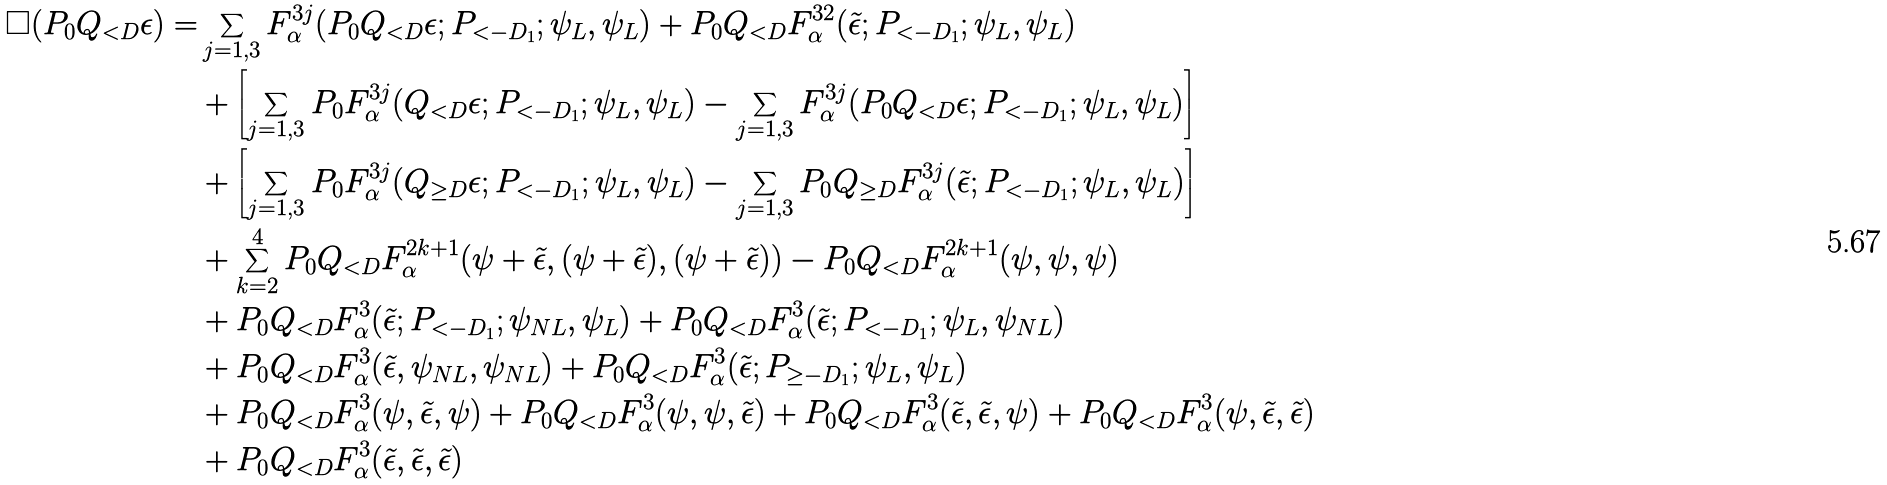<formula> <loc_0><loc_0><loc_500><loc_500>\Box ( P _ { 0 } Q _ { < D } \epsilon ) = & \sum _ { j = 1 , 3 } F _ { \alpha } ^ { 3 j } ( P _ { 0 } Q _ { < D } \epsilon ; P _ { < - D _ { 1 } } ; \psi _ { L } , \psi _ { L } ) + P _ { 0 } Q _ { < D } F _ { \alpha } ^ { 3 2 } ( \tilde { \epsilon } ; P _ { < - D _ { 1 } } ; \psi _ { L } , \psi _ { L } ) \\ & + \left [ \sum _ { j = 1 , 3 } P _ { 0 } F _ { \alpha } ^ { 3 j } ( Q _ { < D } \epsilon ; P _ { < - D _ { 1 } } ; \psi _ { L } , \psi _ { L } ) - \sum _ { j = 1 , 3 } F _ { \alpha } ^ { 3 j } ( P _ { 0 } Q _ { < D } \epsilon ; P _ { < - D _ { 1 } } ; \psi _ { L } , \psi _ { L } ) \right ] \\ & + \left [ \sum _ { j = 1 , 3 } P _ { 0 } F _ { \alpha } ^ { 3 j } ( Q _ { \geq D } \epsilon ; P _ { < - D _ { 1 } } ; \psi _ { L } , \psi _ { L } ) - \sum _ { j = 1 , 3 } P _ { 0 } Q _ { \geq D } F _ { \alpha } ^ { 3 j } ( \tilde { \epsilon } ; P _ { < - D _ { 1 } } ; \psi _ { L } , \psi _ { L } ) \right ] \\ & + \sum _ { k = 2 } ^ { 4 } P _ { 0 } Q _ { < D } F _ { \alpha } ^ { 2 k + 1 } ( \psi + \tilde { \epsilon } , ( \psi + \tilde { \epsilon } ) , ( \psi + \tilde { \epsilon } ) ) - P _ { 0 } Q _ { < D } F _ { \alpha } ^ { 2 k + 1 } ( \psi , \psi , \psi ) \\ & + P _ { 0 } Q _ { < D } F _ { \alpha } ^ { 3 } ( \tilde { \epsilon } ; P _ { < - D _ { 1 } } ; \psi _ { N L } , \psi _ { L } ) + P _ { 0 } Q _ { < D } F _ { \alpha } ^ { 3 } ( \tilde { \epsilon } ; P _ { < - D _ { 1 } } ; \psi _ { L } , \psi _ { N L } ) \\ & + P _ { 0 } Q _ { < D } F _ { \alpha } ^ { 3 } ( \tilde { \epsilon } , \psi _ { N L } , \psi _ { N L } ) + P _ { 0 } Q _ { < D } F _ { \alpha } ^ { 3 } ( \tilde { \epsilon } ; P _ { \geq - D _ { 1 } } ; \psi _ { L } , \psi _ { L } ) \\ & + P _ { 0 } Q _ { < D } F _ { \alpha } ^ { 3 } ( \psi , \tilde { \epsilon } , \psi ) + P _ { 0 } Q _ { < D } F _ { \alpha } ^ { 3 } ( \psi , \psi , \tilde { \epsilon } ) + P _ { 0 } Q _ { < D } F _ { \alpha } ^ { 3 } ( \tilde { \epsilon } , \tilde { \epsilon } , \psi ) + P _ { 0 } Q _ { < D } F _ { \alpha } ^ { 3 } ( \psi , \tilde { \epsilon } , \tilde { \epsilon } ) \\ & + P _ { 0 } Q _ { < D } F _ { \alpha } ^ { 3 } ( \tilde { \epsilon } , \tilde { \epsilon } , \tilde { \epsilon } )</formula> 